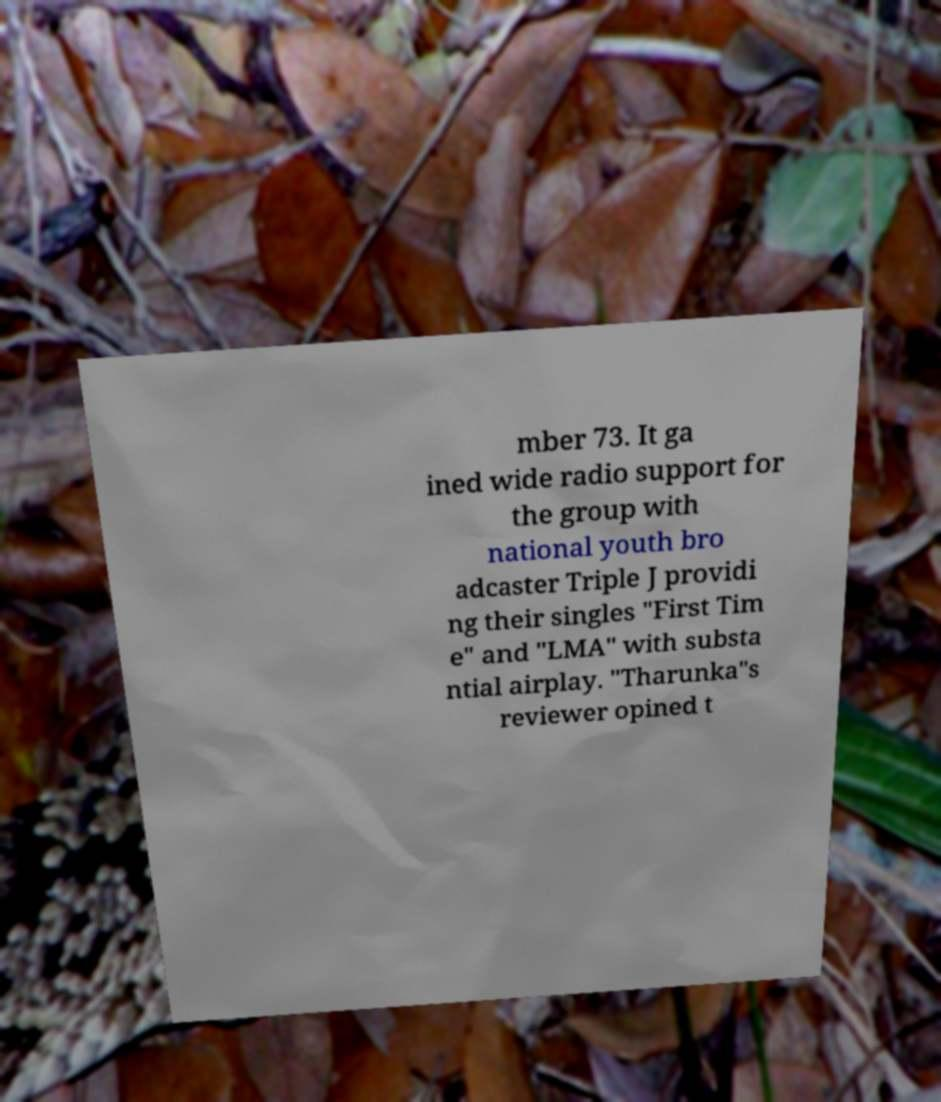Could you extract and type out the text from this image? mber 73. It ga ined wide radio support for the group with national youth bro adcaster Triple J providi ng their singles "First Tim e" and "LMA" with substa ntial airplay. "Tharunka"s reviewer opined t 